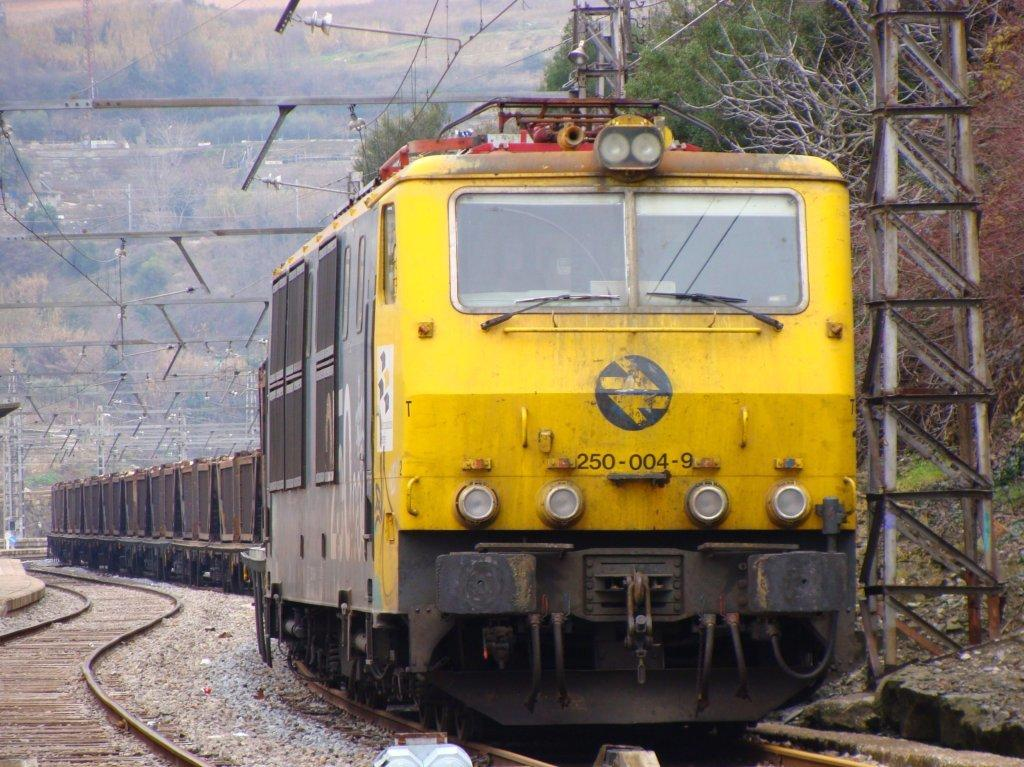<image>
Offer a succinct explanation of the picture presented. Train number 250-004-9 is on the tracks and is painted yellow. 